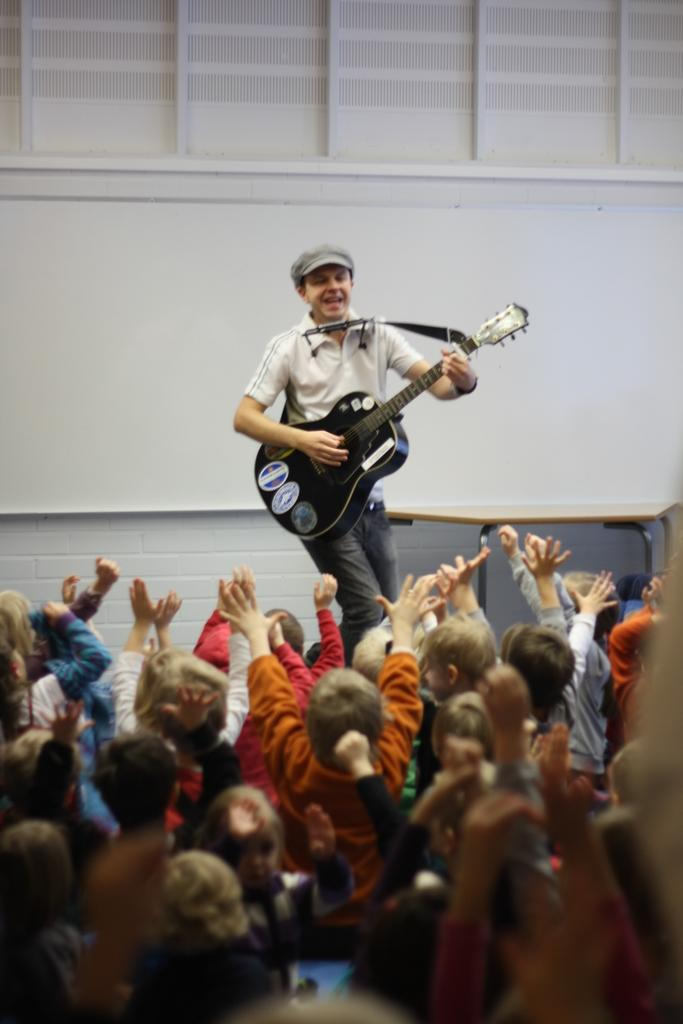Who is the main subject in the image? There is a man in the image. What is the man doing in the image? The man is playing a guitar. Who else is present in the image besides the man? There is an audience in the image. How is the audience reacting to the man? The audience is cheering the man. What type of grass is growing on the wings of the planes in the image? There are no planes or grass present in the image; it features a man playing a guitar and an audience cheering him. 